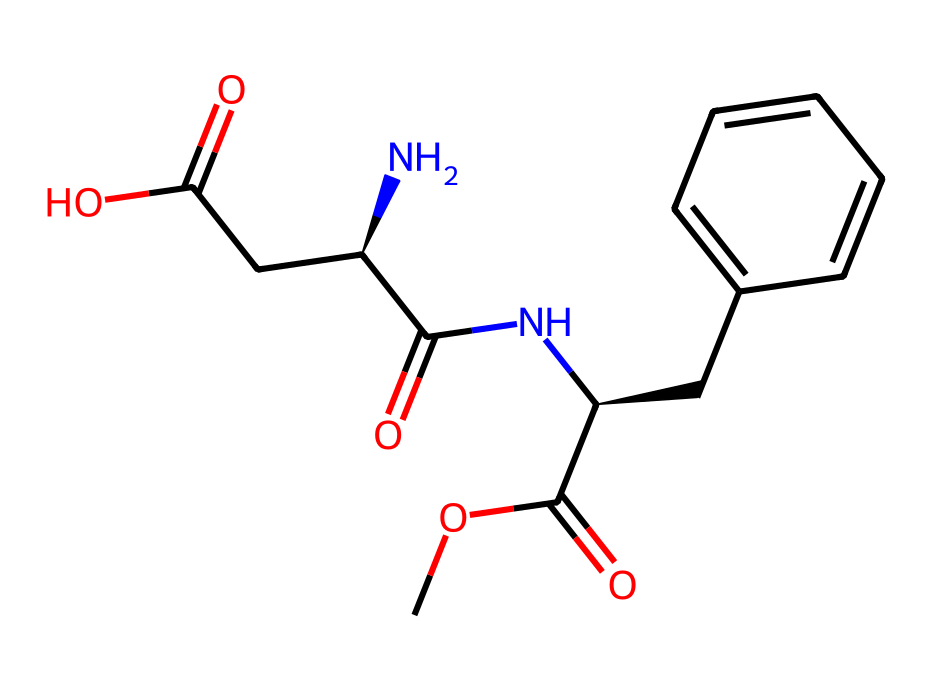What is the total number of carbon atoms in aspartame? By analyzing the SMILES representation, "COC(=O)[C@H](CC1=CC=CC=C1)NC(=O)[C@H](N)CC(=O)O," we can count the carbon atoms. There are 14 carbon atoms represented in the string.
Answer: 14 How many nitrogen atoms does the molecule contain? In the SMILES string, we can identify nitrogen atoms by looking for the letter 'N'. There are two nitrogen atoms present in the molecular structure.
Answer: 2 What type of functional group is present at the terminal end with "C(=O)O"? The "C(=O)O" at the end represents a carboxylic acid functional group, characterized by a carbon atom double-bonded to an oxygen atom and single-bonded to a hydroxyl group (–OH).
Answer: carboxylic acid Which part of the molecule contributes to its sweetness? The presence of the amine group (–NH) and the specific arrangement of carbon chains along with the carboxylic acid enable the interaction with sweet taste receptors, primarily the substituted phenyl ring contributes significantly to the sweetness.
Answer: substituted phenyl ring What is the stereochemical descriptor of the central carbon in the structure? The string "[C@H]" indicates that there is a chiral center at this carbon atom, meaning it has a specific stereochemistry that could affect the sweetness perception.
Answer: chiral center How many oxygen atoms are in the structure? By examining "COC(=O)[C@H](CC1=CC=CC=C1)NC(=O)[C@H](N)CC(=O)O", we can identify the oxygen atoms indicated by 'O', which totals four in this chemical composition.
Answer: 4 